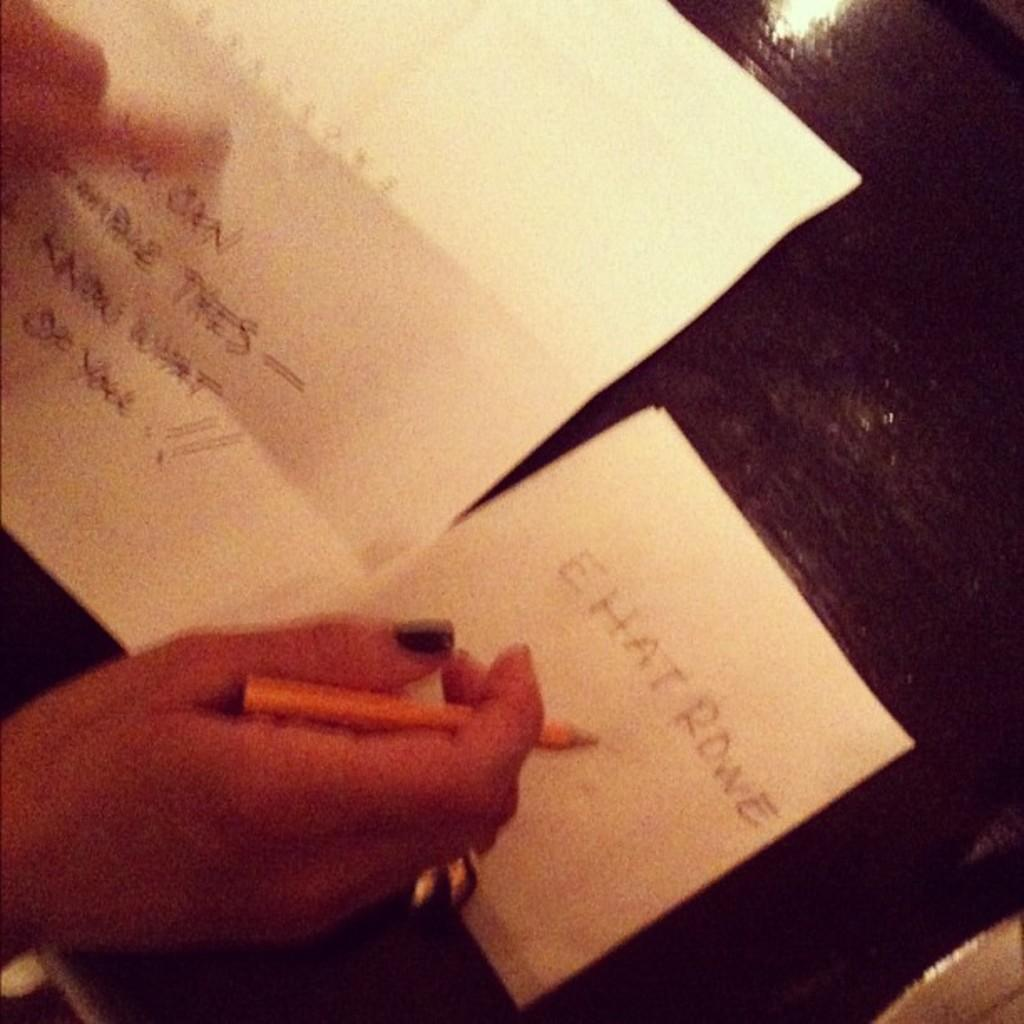What is the main subject in the image? There is a person in the image. What is the person holding in the image? The person is holding a pen. What can be seen on the black surface in the image? There are two papers on the black surface. How many girls are visible in the alley in the image? There are no girls or alleys present in the image. 